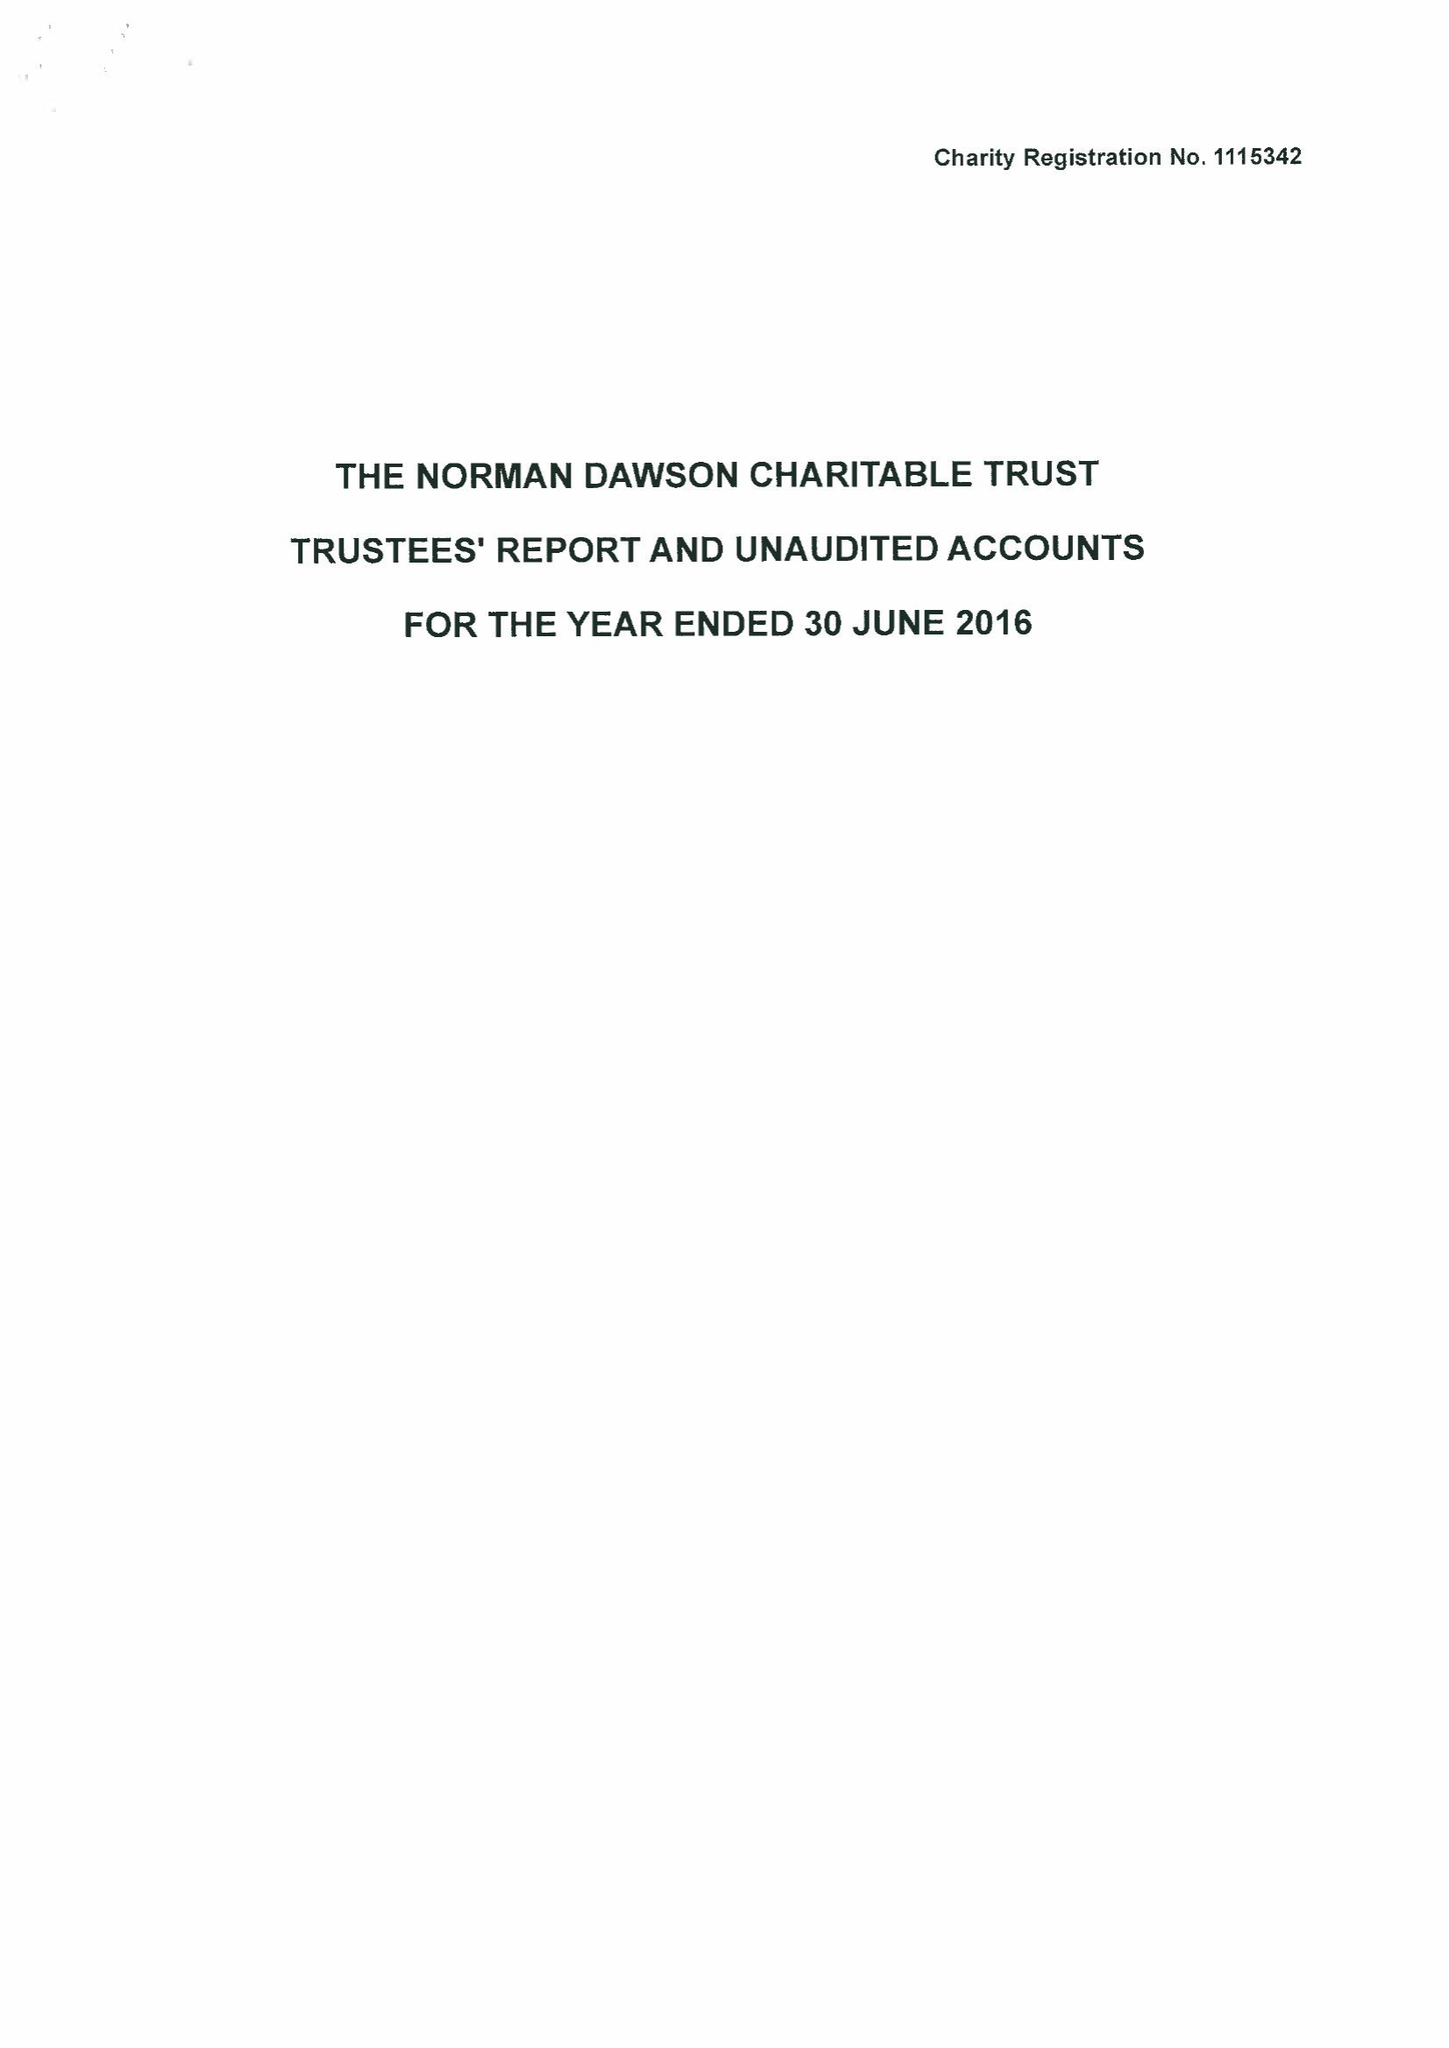What is the value for the charity_number?
Answer the question using a single word or phrase. 1115342 